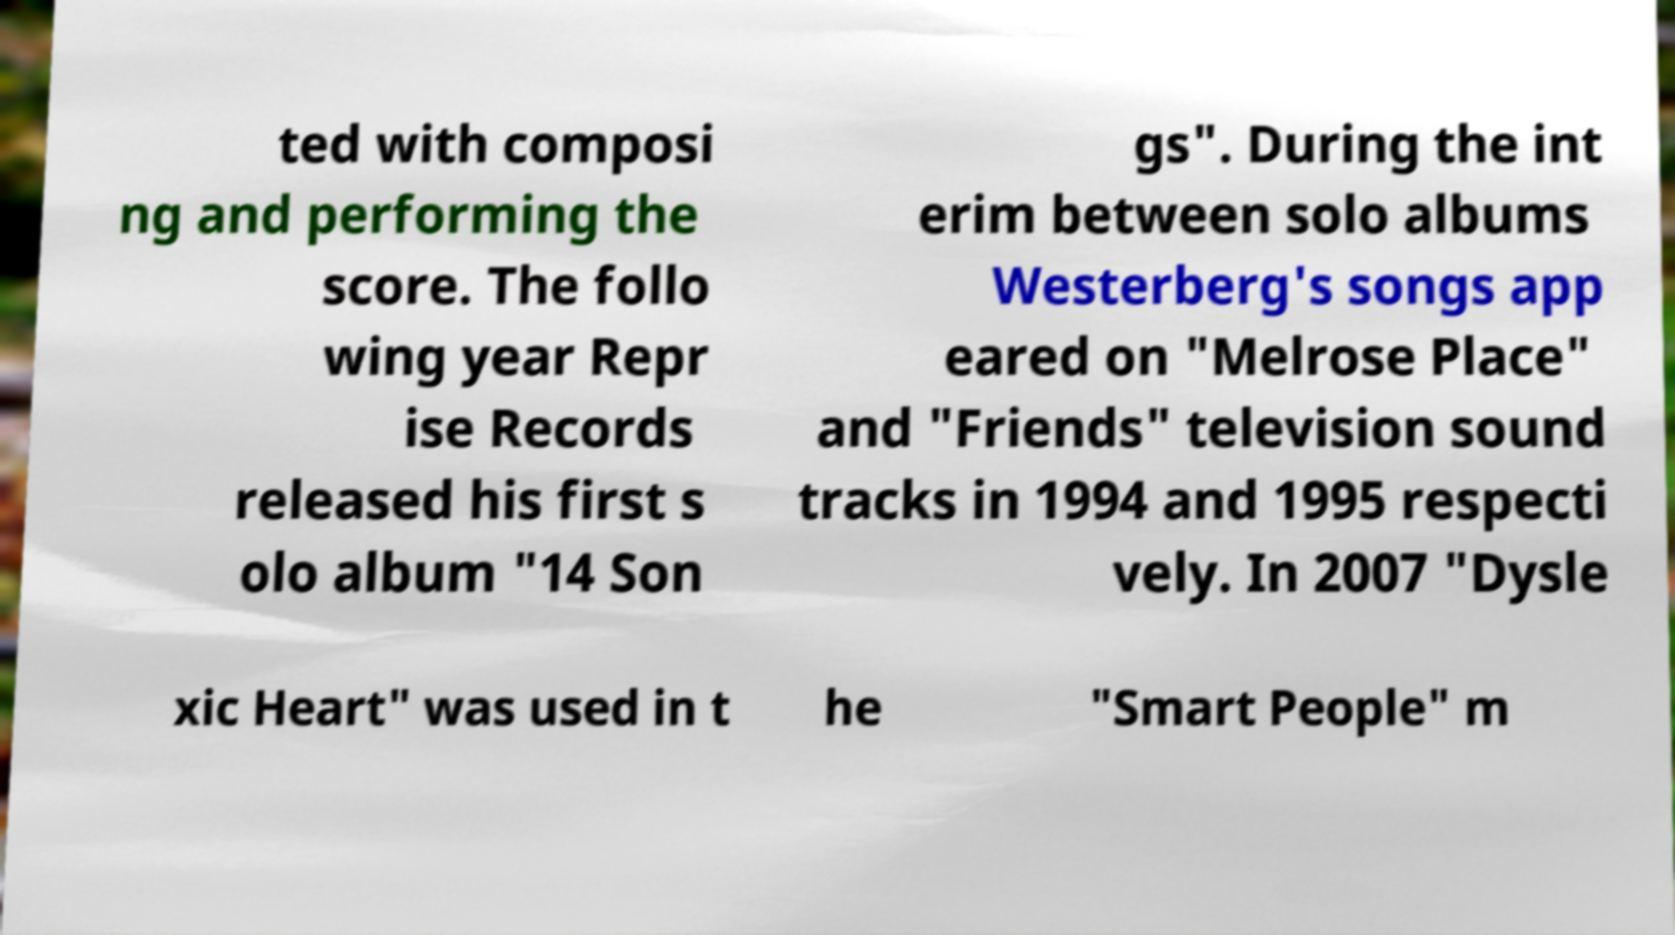What messages or text are displayed in this image? I need them in a readable, typed format. ted with composi ng and performing the score. The follo wing year Repr ise Records released his first s olo album "14 Son gs". During the int erim between solo albums Westerberg's songs app eared on "Melrose Place" and "Friends" television sound tracks in 1994 and 1995 respecti vely. In 2007 "Dysle xic Heart" was used in t he "Smart People" m 